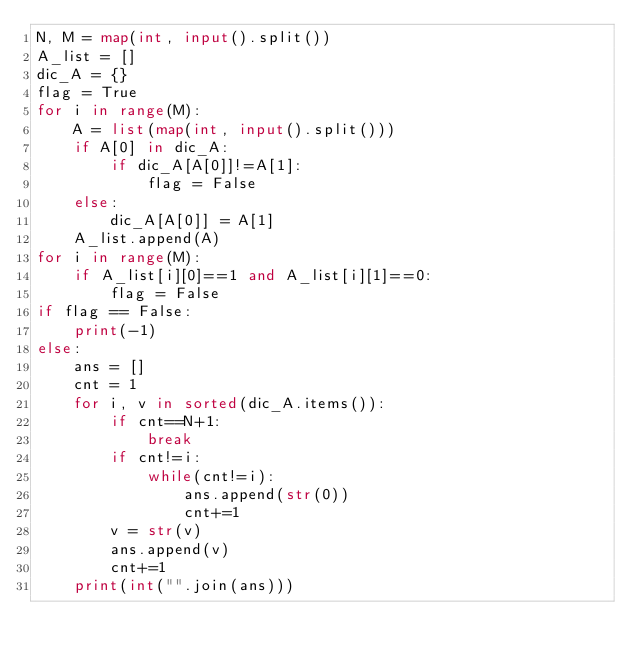Convert code to text. <code><loc_0><loc_0><loc_500><loc_500><_Python_>N, M = map(int, input().split())
A_list = []
dic_A = {}
flag = True
for i in range(M):
    A = list(map(int, input().split()))
    if A[0] in dic_A:
        if dic_A[A[0]]!=A[1]:
            flag = False
    else:
        dic_A[A[0]] = A[1]
    A_list.append(A)
for i in range(M):
    if A_list[i][0]==1 and A_list[i][1]==0:
        flag = False
if flag == False:
    print(-1)
else:
    ans = []
    cnt = 1
    for i, v in sorted(dic_A.items()):
        if cnt==N+1:
            break
        if cnt!=i:
            while(cnt!=i):
                ans.append(str(0))
                cnt+=1
        v = str(v)
        ans.append(v)
        cnt+=1
    print(int("".join(ans)))</code> 